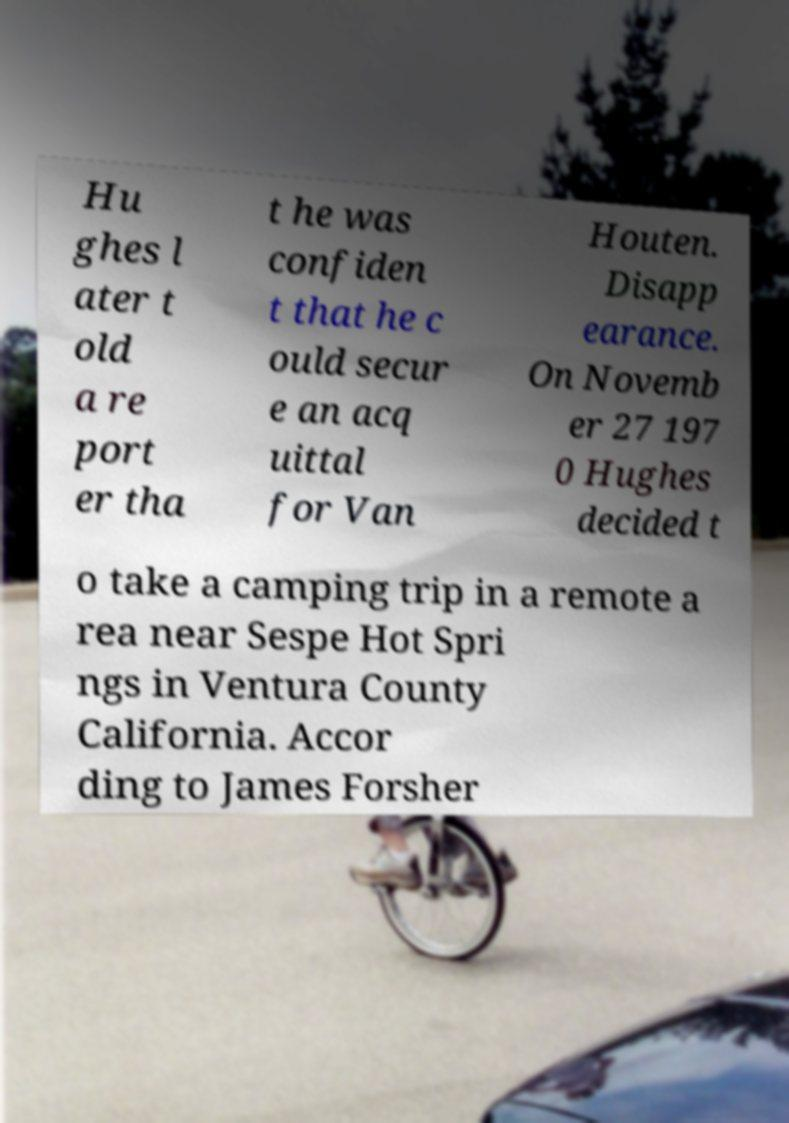Please read and relay the text visible in this image. What does it say? Hu ghes l ater t old a re port er tha t he was confiden t that he c ould secur e an acq uittal for Van Houten. Disapp earance. On Novemb er 27 197 0 Hughes decided t o take a camping trip in a remote a rea near Sespe Hot Spri ngs in Ventura County California. Accor ding to James Forsher 